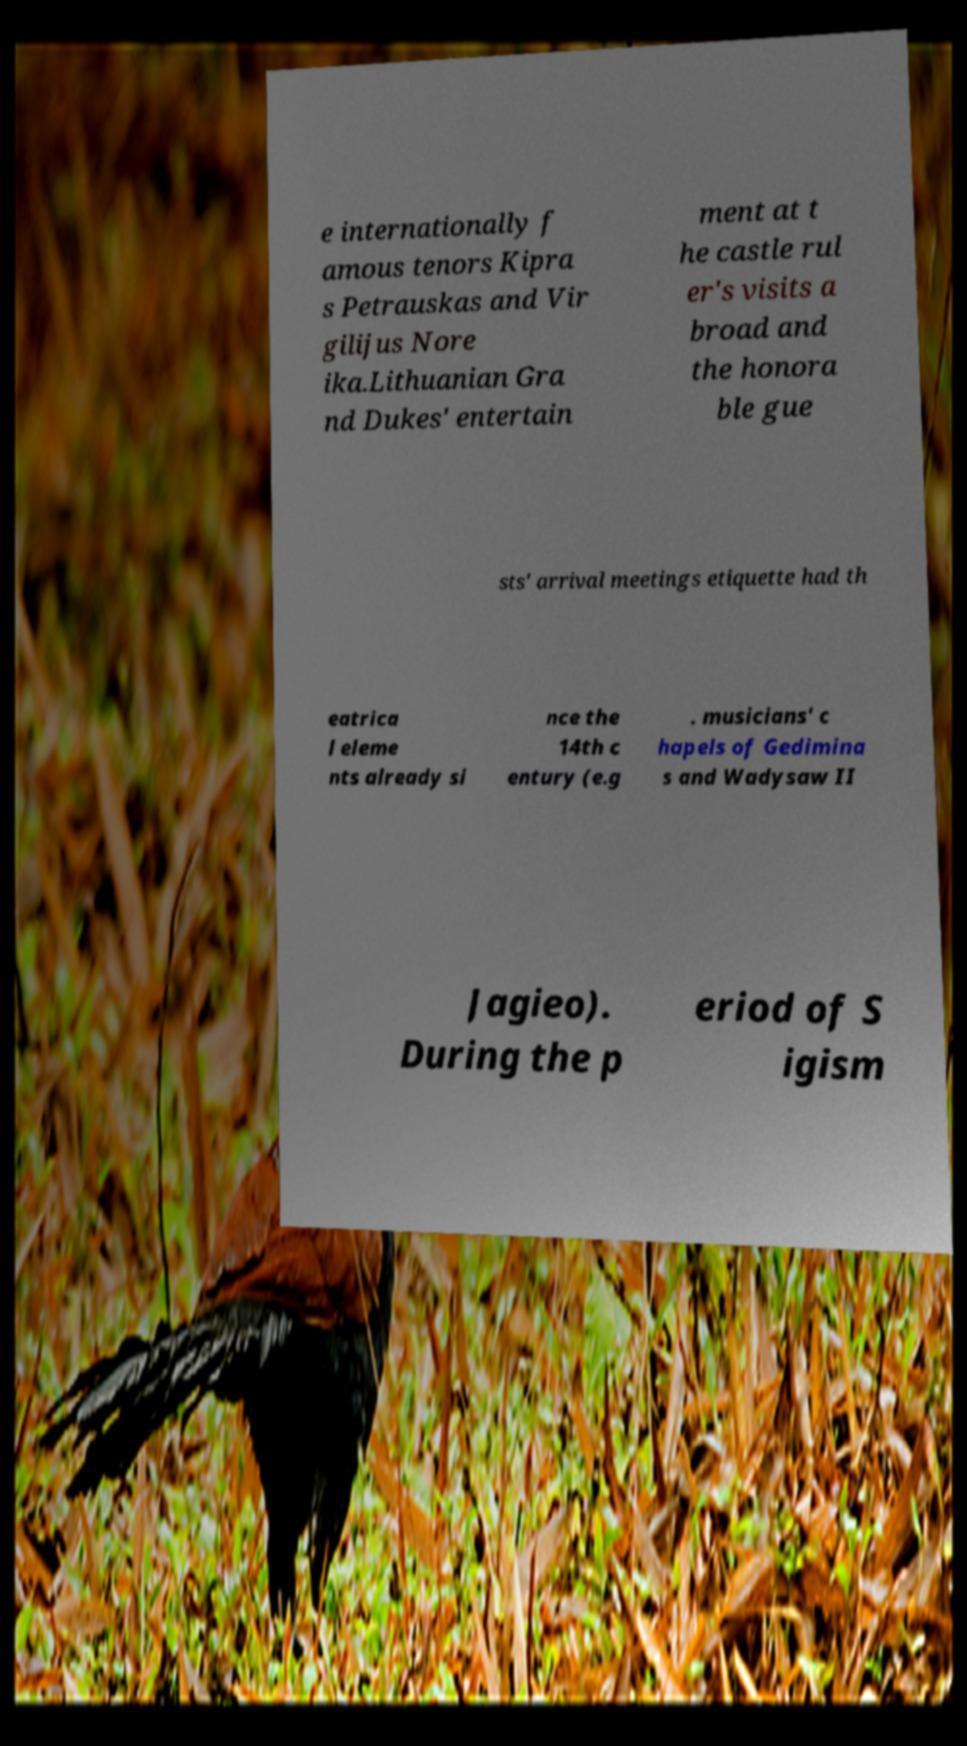Could you assist in decoding the text presented in this image and type it out clearly? e internationally f amous tenors Kipra s Petrauskas and Vir gilijus Nore ika.Lithuanian Gra nd Dukes' entertain ment at t he castle rul er's visits a broad and the honora ble gue sts' arrival meetings etiquette had th eatrica l eleme nts already si nce the 14th c entury (e.g . musicians' c hapels of Gedimina s and Wadysaw II Jagieo). During the p eriod of S igism 